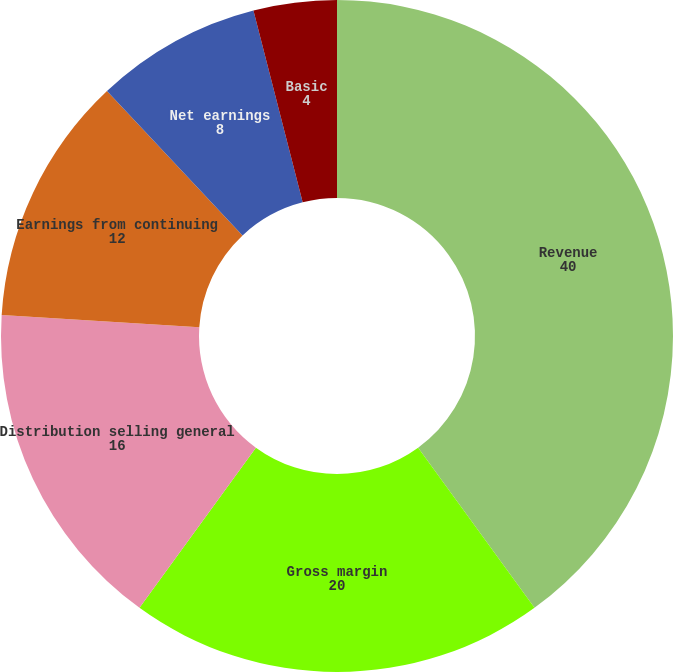Convert chart. <chart><loc_0><loc_0><loc_500><loc_500><pie_chart><fcel>Revenue<fcel>Gross margin<fcel>Distribution selling general<fcel>Earnings from continuing<fcel>Net earnings<fcel>Basic<fcel>Diluted<nl><fcel>40.0%<fcel>20.0%<fcel>16.0%<fcel>12.0%<fcel>8.0%<fcel>4.0%<fcel>0.0%<nl></chart> 